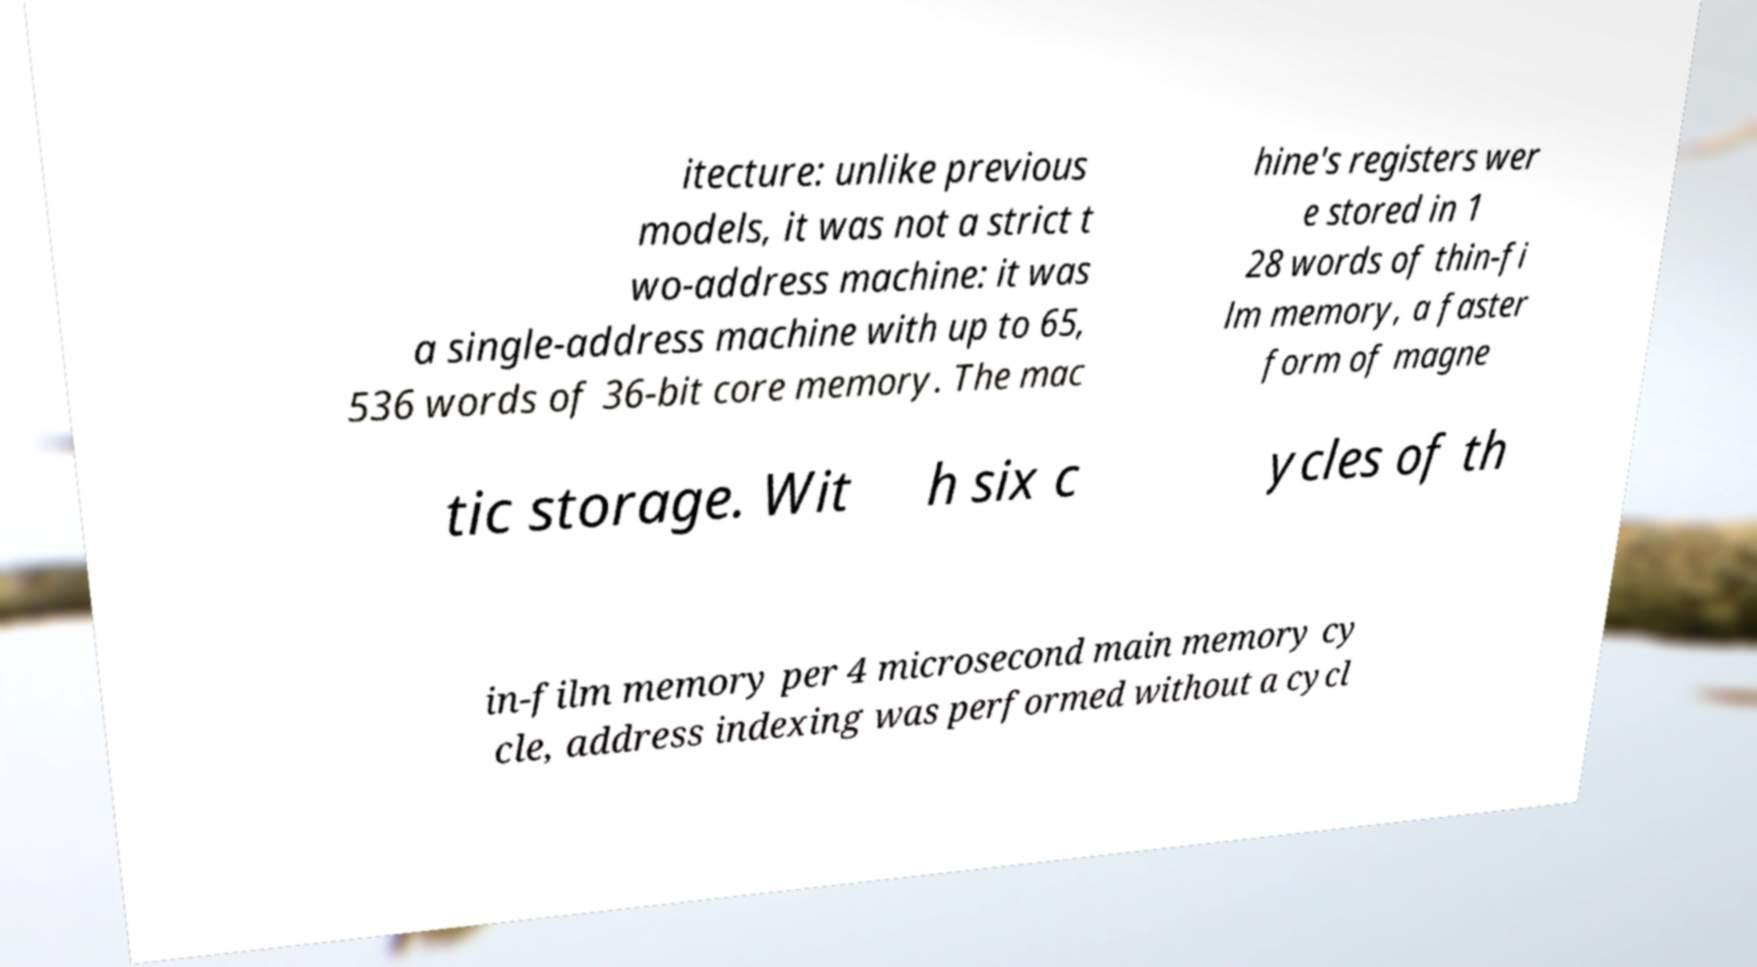There's text embedded in this image that I need extracted. Can you transcribe it verbatim? itecture: unlike previous models, it was not a strict t wo-address machine: it was a single-address machine with up to 65, 536 words of 36-bit core memory. The mac hine's registers wer e stored in 1 28 words of thin-fi lm memory, a faster form of magne tic storage. Wit h six c ycles of th in-film memory per 4 microsecond main memory cy cle, address indexing was performed without a cycl 